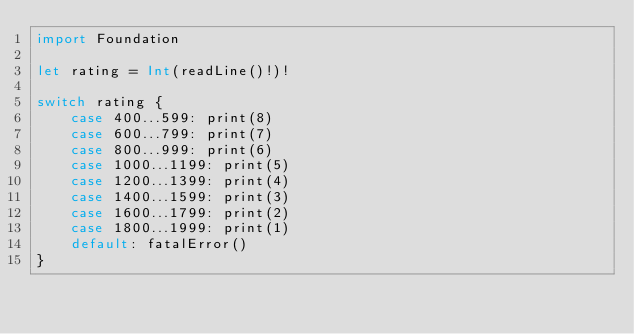<code> <loc_0><loc_0><loc_500><loc_500><_Swift_>import Foundation

let rating = Int(readLine()!)!

switch rating {
    case 400...599: print(8)
    case 600...799: print(7)
    case 800...999: print(6)
    case 1000...1199: print(5)
    case 1200...1399: print(4)
    case 1400...1599: print(3)
    case 1600...1799: print(2)
    case 1800...1999: print(1)
    default: fatalError()
}
</code> 